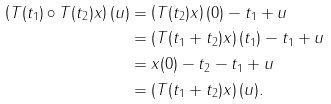<formula> <loc_0><loc_0><loc_500><loc_500>\left ( T ( t _ { 1 } ) \circ T ( t _ { 2 } ) x \right ) ( u ) & = \left ( T ( t _ { 2 } ) x \right ) ( 0 ) - t _ { 1 } + u \\ & = \left ( T ( t _ { 1 } + t _ { 2 } ) x \right ) ( t _ { 1 } ) - t _ { 1 } + u \\ & = x ( 0 ) - t _ { 2 } - t _ { 1 } + u \\ & = \left ( T ( t _ { 1 } + t _ { 2 } ) x \right ) ( u ) .</formula> 